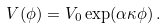<formula> <loc_0><loc_0><loc_500><loc_500>V ( \phi ) = V _ { 0 } \exp ( \alpha \kappa \phi ) \, .</formula> 